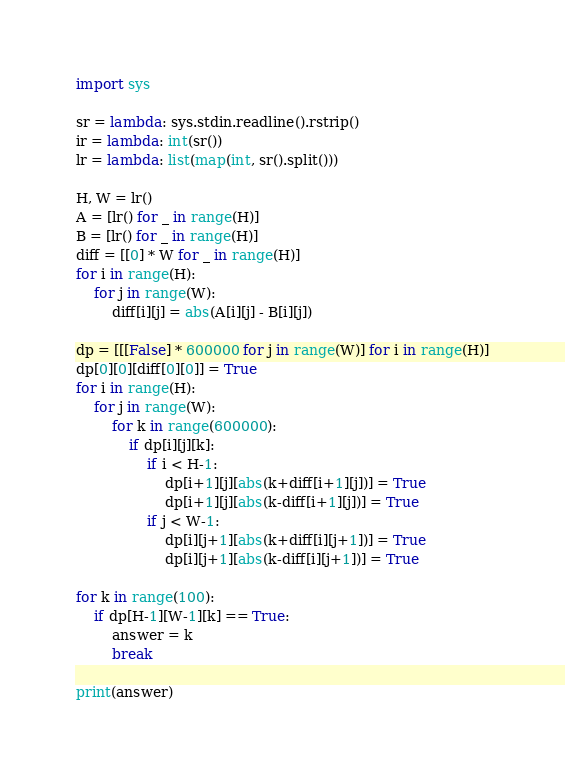Convert code to text. <code><loc_0><loc_0><loc_500><loc_500><_Python_>import sys

sr = lambda: sys.stdin.readline().rstrip()
ir = lambda: int(sr())
lr = lambda: list(map(int, sr().split()))

H, W = lr()
A = [lr() for _ in range(H)]
B = [lr() for _ in range(H)]
diff = [[0] * W for _ in range(H)]
for i in range(H):
    for j in range(W):
        diff[i][j] = abs(A[i][j] - B[i][j])

dp = [[[False] * 600000 for j in range(W)] for i in range(H)]
dp[0][0][diff[0][0]] = True
for i in range(H):
    for j in range(W):
        for k in range(600000):
            if dp[i][j][k]:
                if i < H-1:
                    dp[i+1][j][abs(k+diff[i+1][j])] = True
                    dp[i+1][j][abs(k-diff[i+1][j])] = True
                if j < W-1:
                    dp[i][j+1][abs(k+diff[i][j+1])] = True
                    dp[i][j+1][abs(k-diff[i][j+1])] = True

for k in range(100):
    if dp[H-1][W-1][k] == True:
        answer = k
        break

print(answer)
</code> 